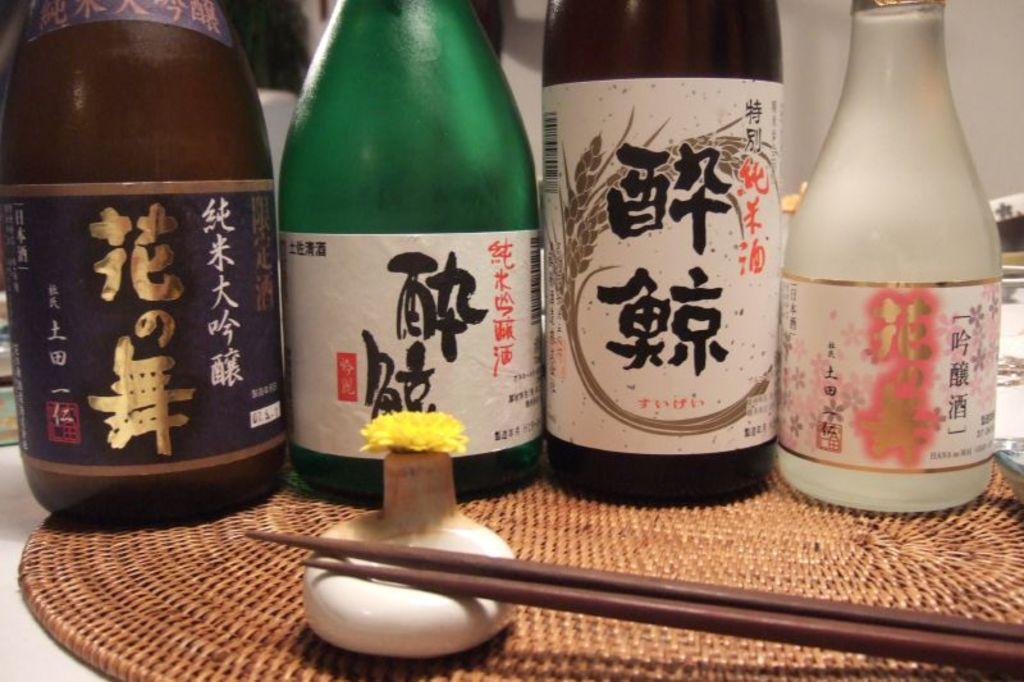What piece of furniture is in the image? There is a table in the image. What utensils can be seen on the table? Chopsticks are present on the table. What else is on the table besides chopsticks? Decorative items, bottles, and a table coaster are visible on the table. What can be seen in the background of the image? There is a wall in the background of the image. How many horses are visible in the image? There are no horses present in the image. What causes the bottles to be on the table? The provided facts do not mention a cause for the bottles being on the table; they are simply present. 